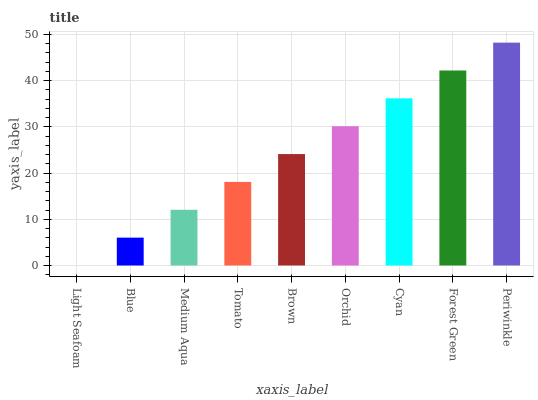Is Light Seafoam the minimum?
Answer yes or no. Yes. Is Periwinkle the maximum?
Answer yes or no. Yes. Is Blue the minimum?
Answer yes or no. No. Is Blue the maximum?
Answer yes or no. No. Is Blue greater than Light Seafoam?
Answer yes or no. Yes. Is Light Seafoam less than Blue?
Answer yes or no. Yes. Is Light Seafoam greater than Blue?
Answer yes or no. No. Is Blue less than Light Seafoam?
Answer yes or no. No. Is Brown the high median?
Answer yes or no. Yes. Is Brown the low median?
Answer yes or no. Yes. Is Medium Aqua the high median?
Answer yes or no. No. Is Tomato the low median?
Answer yes or no. No. 